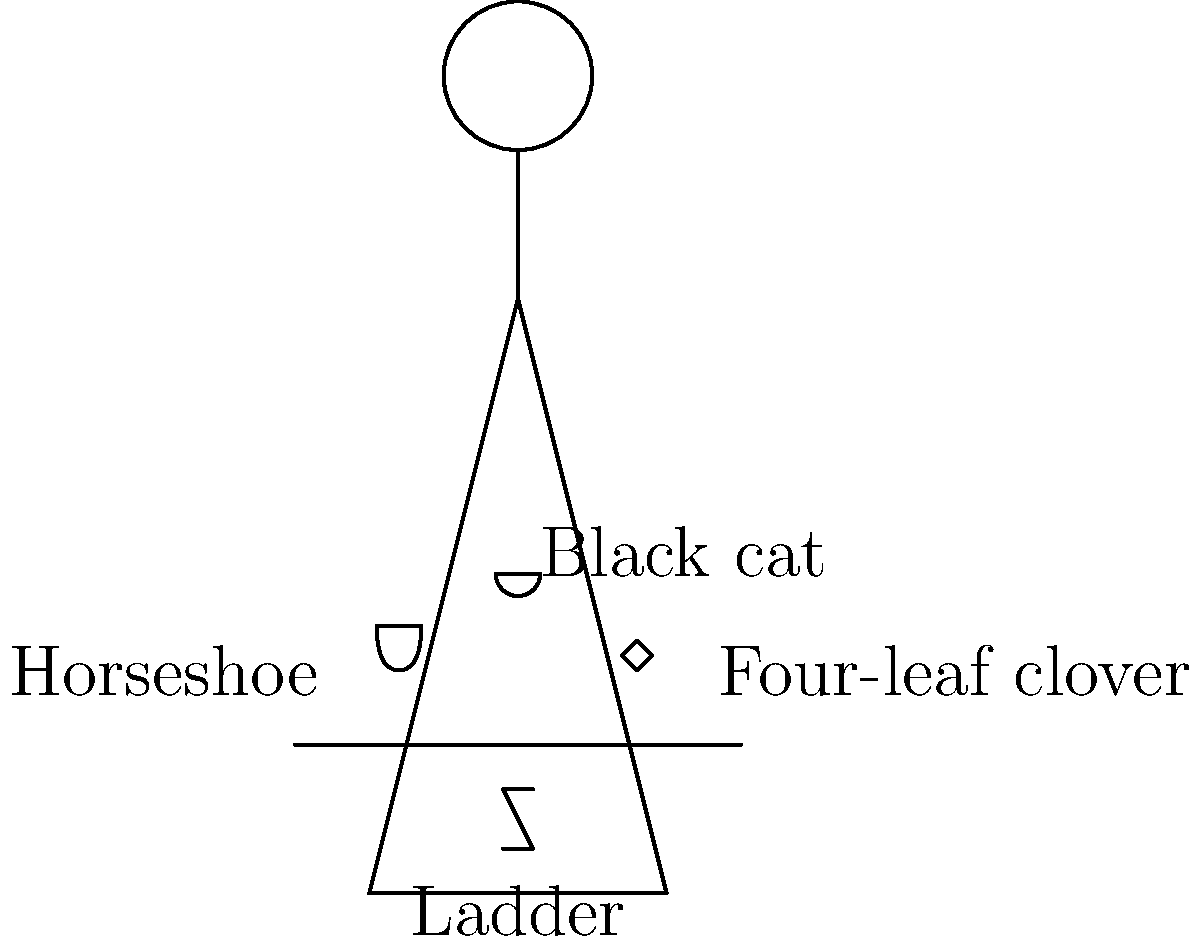Analyze the comedian's outfit in the image. How many superstitious symbols are present, and what is the predicted confidence level based on the number and type of symbols? To determine the comedian's predicted confidence level, we need to:

1. Identify the superstitious symbols in the outfit:
   a. Horseshoe
   b. Four-leaf clover
   c. Ladder
   d. Black cat

2. Count the number of symbols: There are 4 symbols present.

3. Assess the impact of each symbol:
   a. Horseshoe: Considered lucky, +1 to confidence
   b. Four-leaf clover: Very lucky, +2 to confidence
   c. Ladder: Often considered unlucky, -1 to confidence
   d. Black cat: Typically seen as unlucky, -1 to confidence

4. Calculate the overall confidence score:
   Confidence score = (+1) + (+2) + (-1) + (-1) = +1

5. Interpret the score:
   A positive score indicates a slight boost in confidence, despite the presence of some unlucky symbols. The lucky symbols (horseshoe and four-leaf clover) outweigh the unlucky ones (ladder and black cat).

Therefore, based on the superstitious symbols present in the comedian's outfit, we can predict a slightly elevated confidence level.
Answer: Slightly elevated confidence 